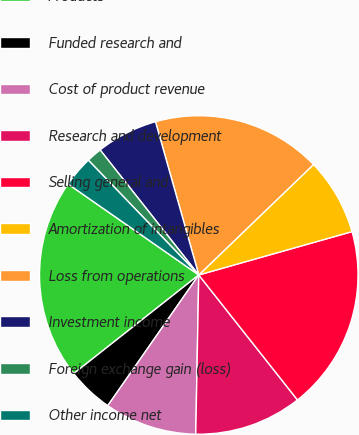Convert chart to OTSL. <chart><loc_0><loc_0><loc_500><loc_500><pie_chart><fcel>Products<fcel>Funded research and<fcel>Cost of product revenue<fcel>Research and development<fcel>Selling general and<fcel>Amortization of intangibles<fcel>Loss from operations<fcel>Investment income<fcel>Foreign exchange gain (loss)<fcel>Other income net<nl><fcel>20.31%<fcel>4.69%<fcel>9.38%<fcel>10.94%<fcel>18.75%<fcel>7.81%<fcel>17.19%<fcel>6.25%<fcel>1.56%<fcel>3.13%<nl></chart> 